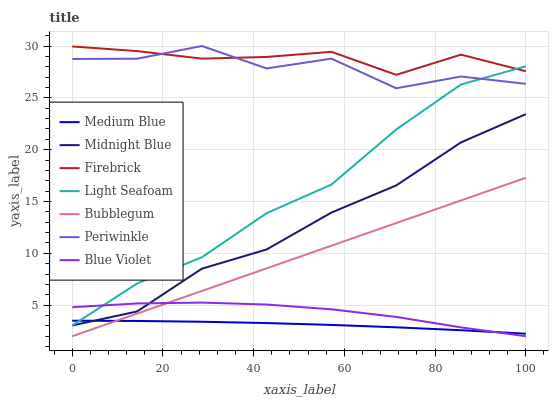Does Medium Blue have the minimum area under the curve?
Answer yes or no. Yes. Does Firebrick have the maximum area under the curve?
Answer yes or no. Yes. Does Firebrick have the minimum area under the curve?
Answer yes or no. No. Does Medium Blue have the maximum area under the curve?
Answer yes or no. No. Is Bubblegum the smoothest?
Answer yes or no. Yes. Is Periwinkle the roughest?
Answer yes or no. Yes. Is Firebrick the smoothest?
Answer yes or no. No. Is Firebrick the roughest?
Answer yes or no. No. Does Bubblegum have the lowest value?
Answer yes or no. Yes. Does Medium Blue have the lowest value?
Answer yes or no. No. Does Periwinkle have the highest value?
Answer yes or no. Yes. Does Firebrick have the highest value?
Answer yes or no. No. Is Bubblegum less than Firebrick?
Answer yes or no. Yes. Is Light Seafoam greater than Bubblegum?
Answer yes or no. Yes. Does Light Seafoam intersect Medium Blue?
Answer yes or no. Yes. Is Light Seafoam less than Medium Blue?
Answer yes or no. No. Is Light Seafoam greater than Medium Blue?
Answer yes or no. No. Does Bubblegum intersect Firebrick?
Answer yes or no. No. 